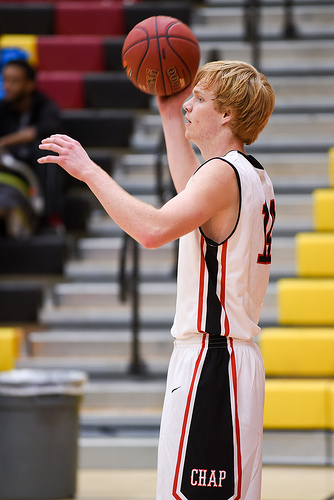<image>
Is the bleacher behind the basketball? Yes. From this viewpoint, the bleacher is positioned behind the basketball, with the basketball partially or fully occluding the bleacher. Is there a basketball behind the man? No. The basketball is not behind the man. From this viewpoint, the basketball appears to be positioned elsewhere in the scene. 